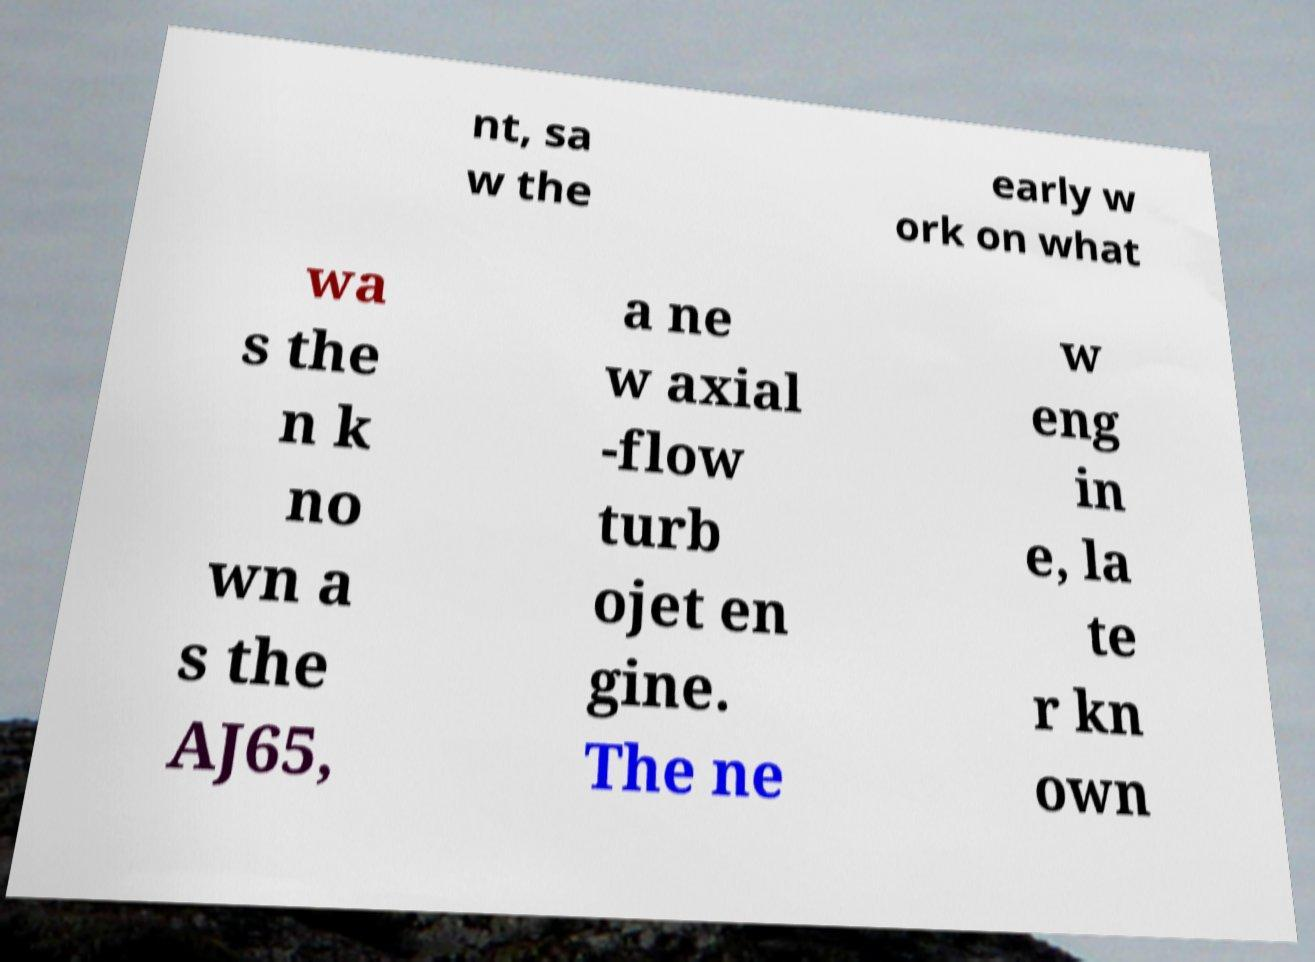I need the written content from this picture converted into text. Can you do that? nt, sa w the early w ork on what wa s the n k no wn a s the AJ65, a ne w axial -flow turb ojet en gine. The ne w eng in e, la te r kn own 